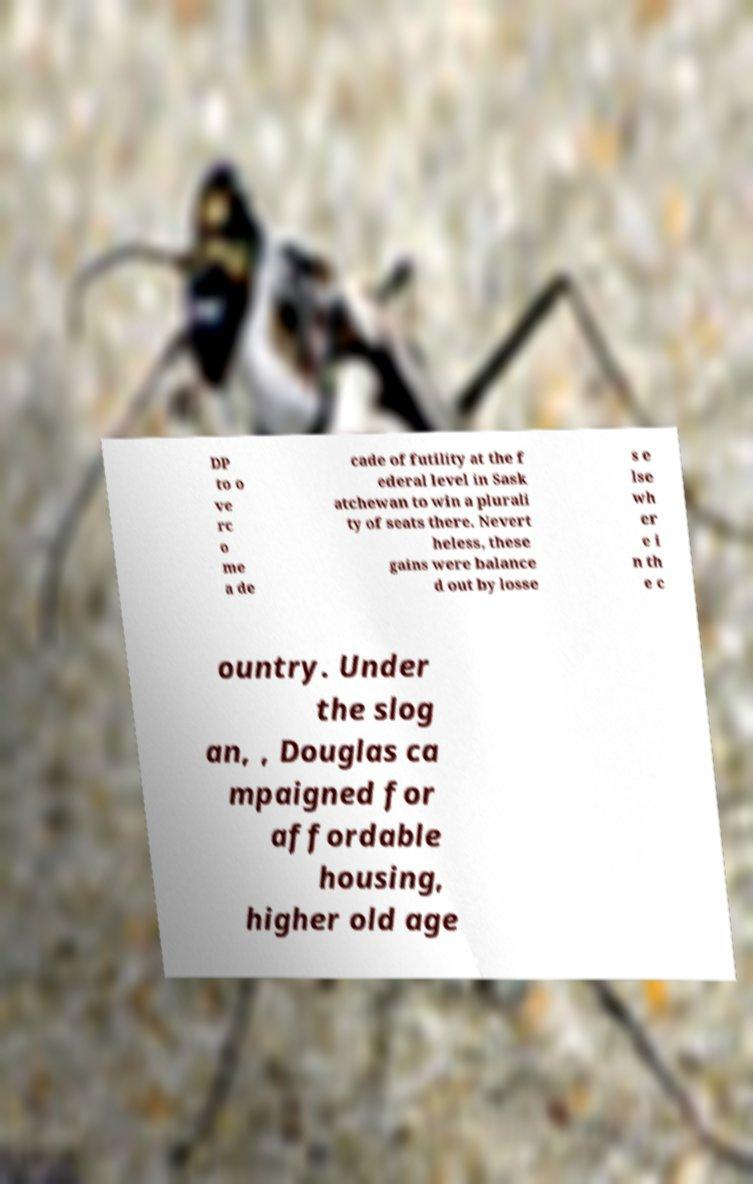For documentation purposes, I need the text within this image transcribed. Could you provide that? DP to o ve rc o me a de cade of futility at the f ederal level in Sask atchewan to win a plurali ty of seats there. Nevert heless, these gains were balance d out by losse s e lse wh er e i n th e c ountry. Under the slog an, , Douglas ca mpaigned for affordable housing, higher old age 